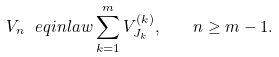<formula> <loc_0><loc_0><loc_500><loc_500>V _ { n } \ e q i n l a w \sum _ { k = 1 } ^ { m } V _ { J _ { k } } ^ { ( k ) } , \quad n \geq m - 1 .</formula> 